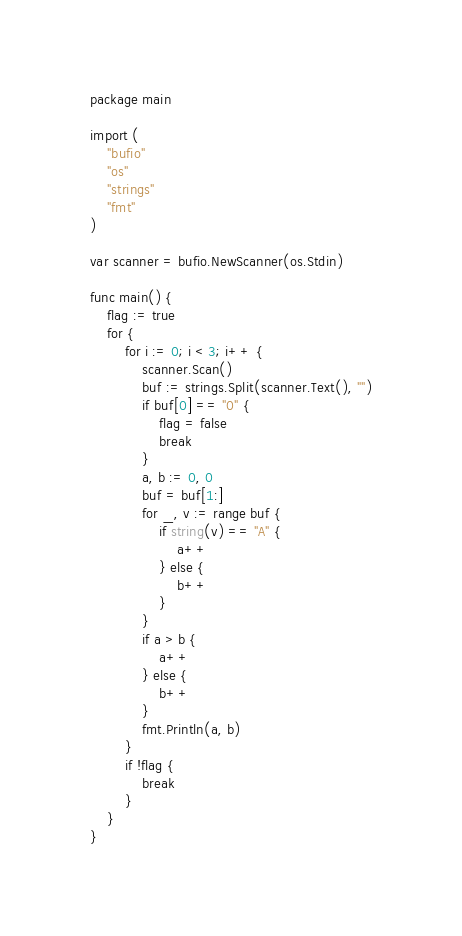Convert code to text. <code><loc_0><loc_0><loc_500><loc_500><_Go_>package main

import (
	"bufio"
	"os"
	"strings"
	"fmt"
)

var scanner = bufio.NewScanner(os.Stdin)

func main() {
	flag := true
	for {
		for i := 0; i < 3; i++ {
			scanner.Scan()
			buf := strings.Split(scanner.Text(), "")
			if buf[0] == "0" {
				flag = false
				break
			}
			a, b := 0, 0
			buf = buf[1:]
			for _, v := range buf {
				if string(v) == "A" {
					a++
				} else {
					b++
				}
			}
			if a > b {
				a++
			} else {
				b++
			}
			fmt.Println(a, b)
		}
		if !flag {
			break
		}
	}
}
</code> 